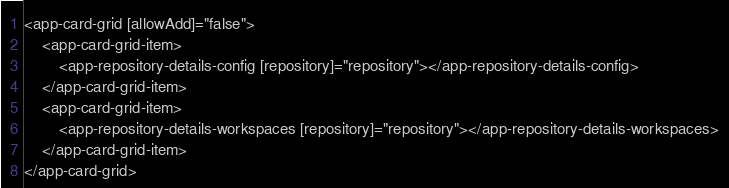Convert code to text. <code><loc_0><loc_0><loc_500><loc_500><_HTML_><app-card-grid [allowAdd]="false">
    <app-card-grid-item>
        <app-repository-details-config [repository]="repository"></app-repository-details-config>
    </app-card-grid-item>
    <app-card-grid-item>
        <app-repository-details-workspaces [repository]="repository"></app-repository-details-workspaces>
    </app-card-grid-item>
</app-card-grid>
</code> 